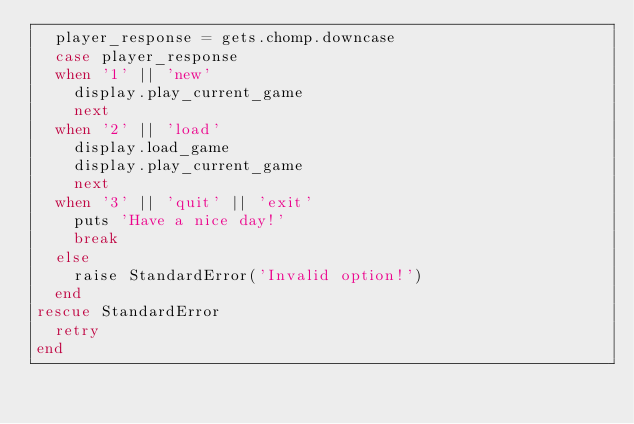Convert code to text. <code><loc_0><loc_0><loc_500><loc_500><_Ruby_>  player_response = gets.chomp.downcase
  case player_response
  when '1' || 'new'
    display.play_current_game
    next
  when '2' || 'load'
    display.load_game
    display.play_current_game
    next
  when '3' || 'quit' || 'exit'
    puts 'Have a nice day!'
    break
  else
    raise StandardError('Invalid option!')
  end
rescue StandardError
  retry
end
</code> 